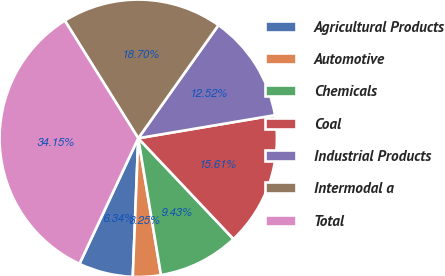Convert chart. <chart><loc_0><loc_0><loc_500><loc_500><pie_chart><fcel>Agricultural Products<fcel>Automotive<fcel>Chemicals<fcel>Coal<fcel>Industrial Products<fcel>Intermodal a<fcel>Total<nl><fcel>6.34%<fcel>3.25%<fcel>9.43%<fcel>15.61%<fcel>12.52%<fcel>18.7%<fcel>34.15%<nl></chart> 